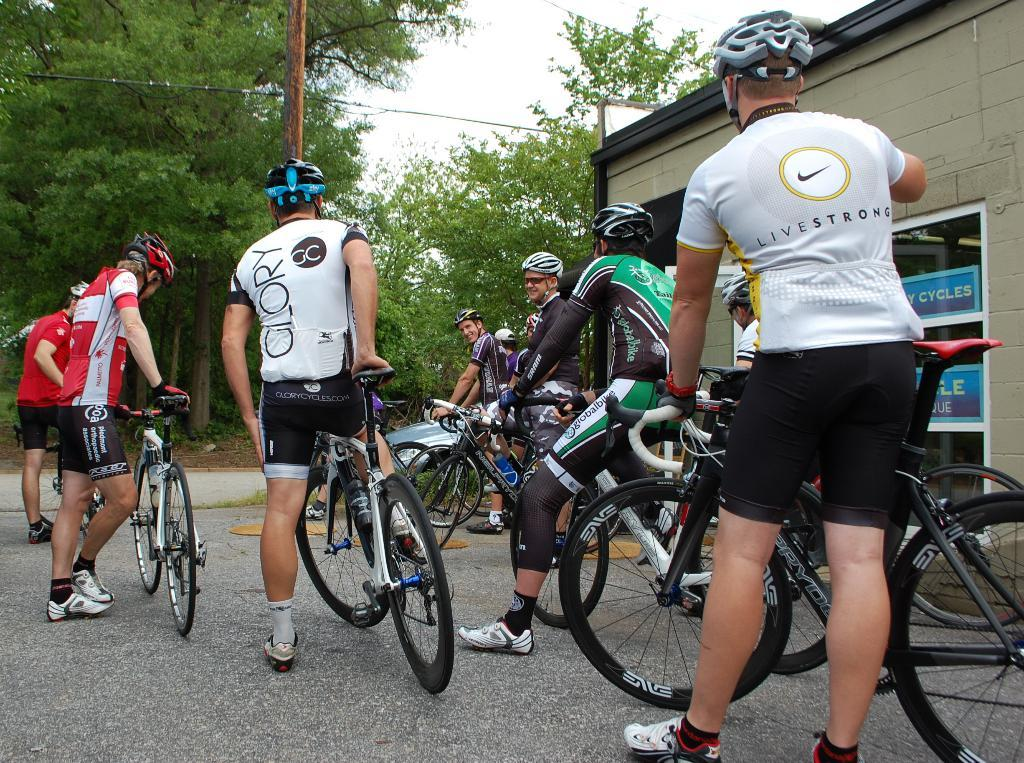What are the people in the image doing? The people in the image are sitting on a bicycle. What can be seen in the background of the image? There is a building and trees in the background of the image. What type of board is the doll using to surf in the image? There is no board or doll present in the image; it features people sitting on a bicycle with a background of a building and trees. 